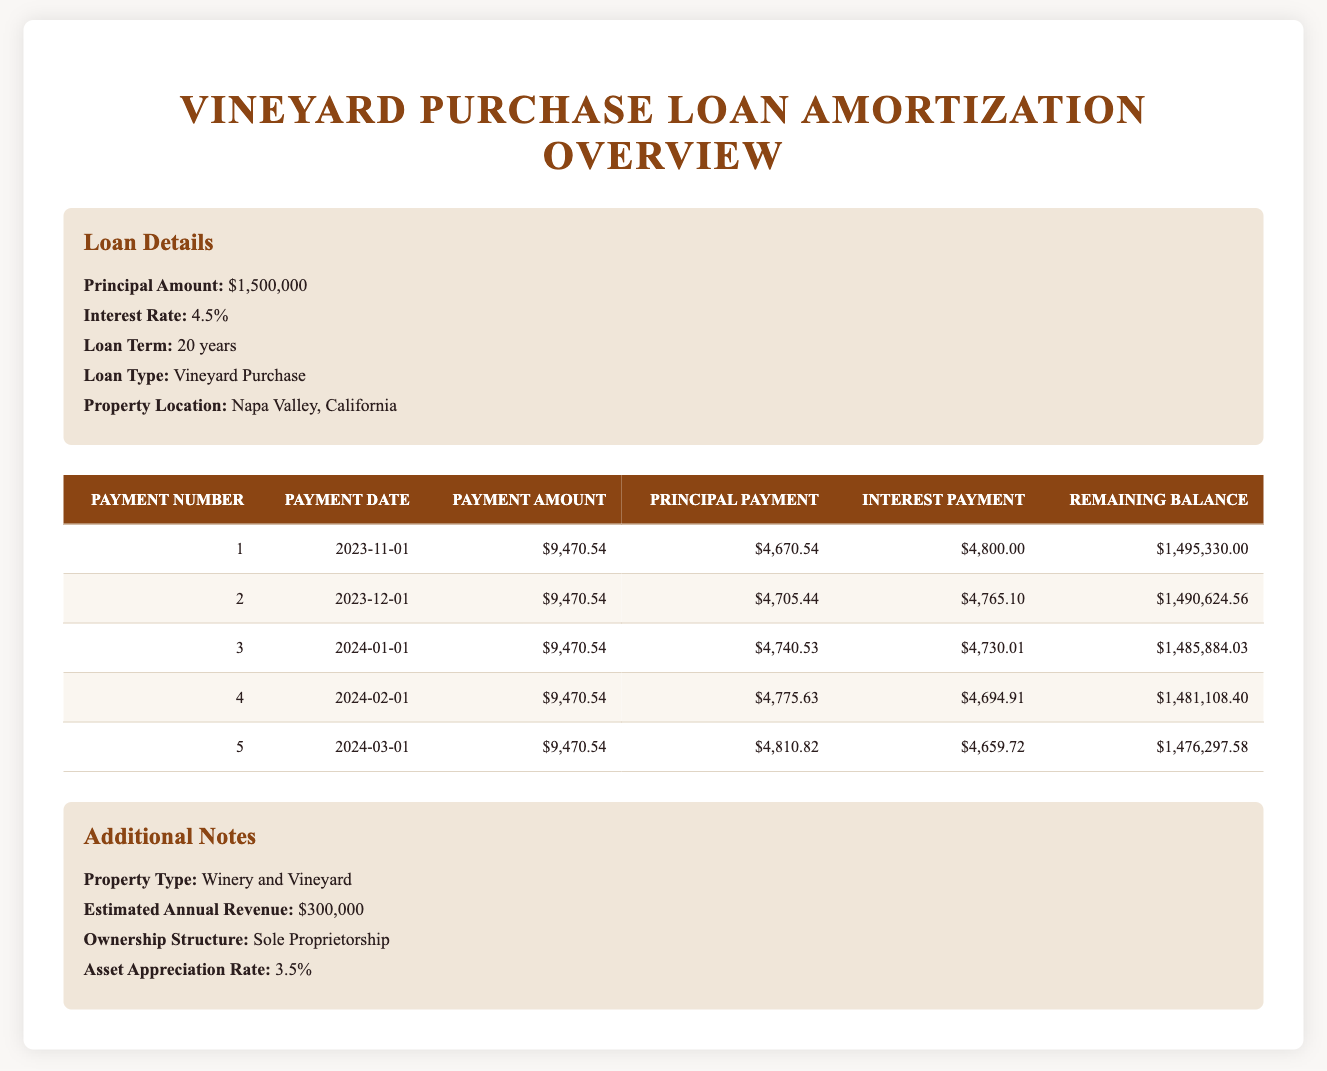What is the monthly payment amount for the loan? The payment amount is stated in each row of the table under the "Payment Amount" column. All the values listed in this column are the same, $9,470.54. Therefore, this is the monthly payment amount for the loan.
Answer: 9,470.54 How much of the first payment goes to interest? To find the interest portion of the first payment, we look at the "Interest Payment" column for the first payment number. The value listed is $4,800.00. This indicates that $4,800.00 of the first payment goes toward interest.
Answer: 4,800.00 What is the total principal paid after the first five payments? We must sum the "Principal Payment" values for the first five payment entries. The total is calculated as follows: 4,670.54 + 4,705.44 + 4,740.53 + 4,775.63 + 4,810.82 = 23,702.96. Therefore, this is the total principal paid after the first five payments.
Answer: 23,702.96 Is the interest payment for the second month higher than the first month? Comparing the "Interest Payment" values for the first and second months, we see $4,800.00 for the first month and $4,765.10 for the second month. Since $4,800.00 > $4,765.10, the interest payment for the first month is higher than for the second month. Thus, the answer is no.
Answer: No What is the remaining balance after the fifth payment? The remaining balance can be found in the "Remaining Balance" column for the fifth payment entry. The value is $1,476,297.58, indicating this is the remaining loan balance after the fifth payment.
Answer: 1,476,297.58 What is the average principal payment over the first five payments? To find the average principal payment, we sum the "Principal Payment" values for the first five payments: 4,670.54 + 4,705.44 + 4,740.53 + 4,775.63 + 4,810.82 = 23,702.96. Then we divide this total by 5 (the number of payments): 23,702.96 / 5 = 4,740.592. Thus, rounding this gives an average principal payment of approximately 4,740.59.
Answer: 4,740.59 How has the remaining balance reduced from the first payment to the fifth payment? The remaining balance after the first payment is $1,495,330.00 and after the fifth payment is $1,476,297.58. The reduction can be calculated as $1,495,330.00 - $1,476,297.58 = $19,032.42. This means the remaining balance has reduced by $19,032.42 from the first to the fifth payment.
Answer: 19,032.42 Does the principal payment increase with each consecutive month? To determine this, we compare the principal payments across the first five rows: 4,670.54, 4,705.44, 4,740.53, 4,775.63, and 4,810.82. Each payment shows an increase from the previous one. Therefore, the principal payment does indeed increase every month. So, the answer is yes.
Answer: Yes 